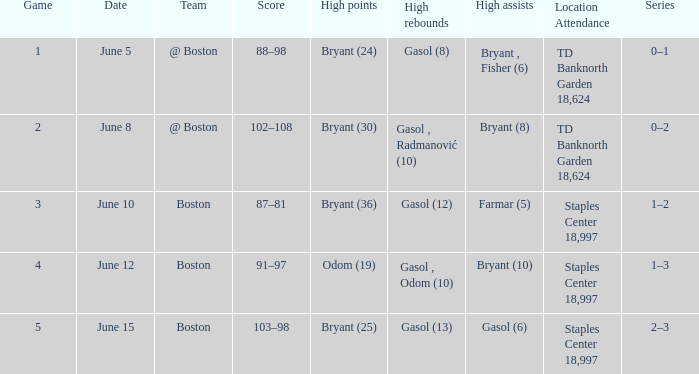Specify the venue on june 10. Staples Center 18,997. 